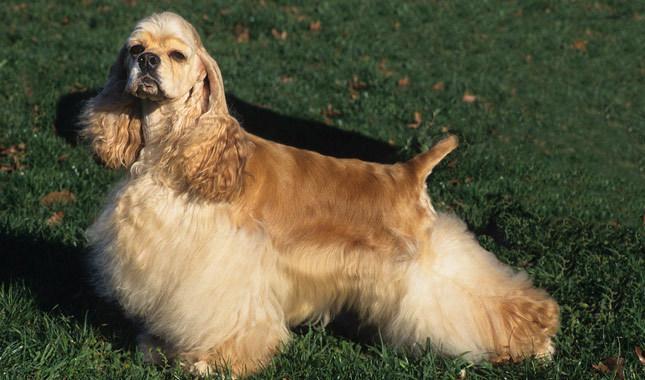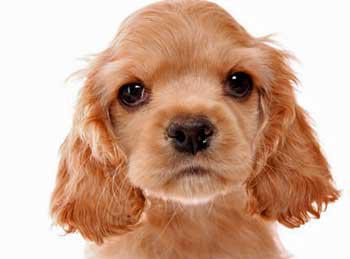The first image is the image on the left, the second image is the image on the right. Considering the images on both sides, is "The right image shows a young puppy." valid? Answer yes or no. Yes. 